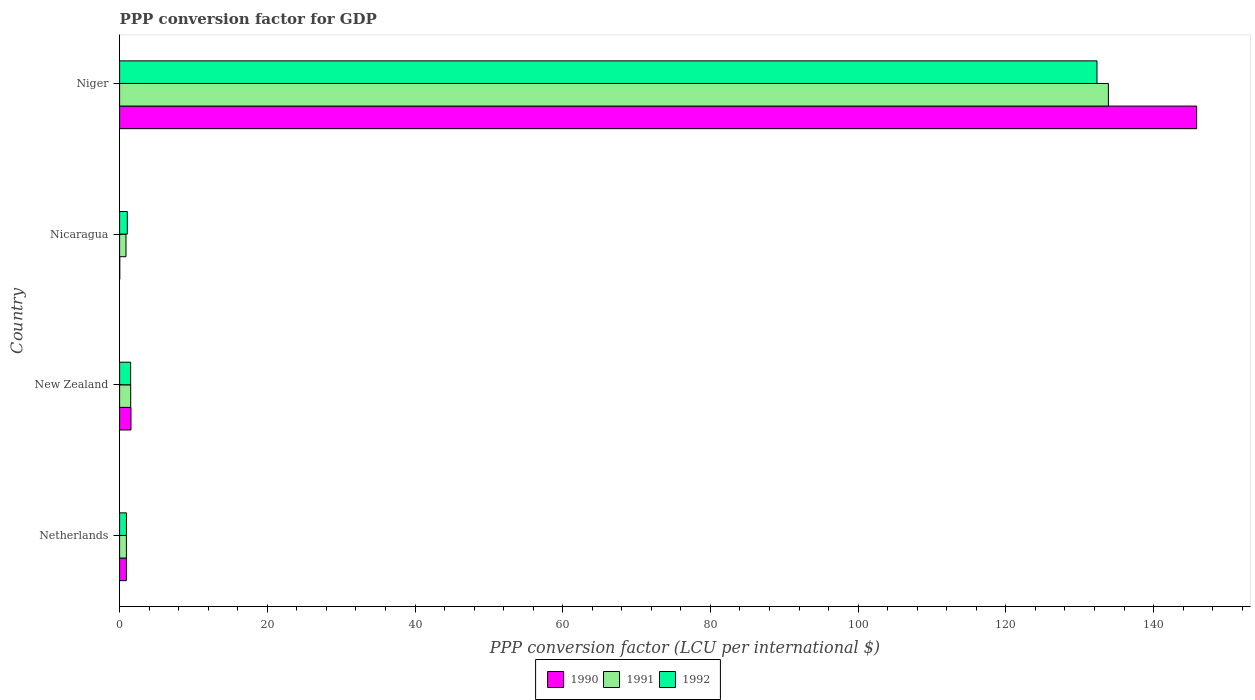How many bars are there on the 3rd tick from the top?
Provide a succinct answer. 3. What is the label of the 2nd group of bars from the top?
Keep it short and to the point. Nicaragua. What is the PPP conversion factor for GDP in 1990 in Nicaragua?
Keep it short and to the point. 0.02. Across all countries, what is the maximum PPP conversion factor for GDP in 1990?
Your answer should be compact. 145.83. Across all countries, what is the minimum PPP conversion factor for GDP in 1991?
Your answer should be very brief. 0.87. In which country was the PPP conversion factor for GDP in 1991 maximum?
Provide a succinct answer. Niger. In which country was the PPP conversion factor for GDP in 1991 minimum?
Give a very brief answer. Nicaragua. What is the total PPP conversion factor for GDP in 1990 in the graph?
Make the answer very short. 148.32. What is the difference between the PPP conversion factor for GDP in 1991 in Netherlands and that in Nicaragua?
Your answer should be very brief. 0.06. What is the difference between the PPP conversion factor for GDP in 1992 in New Zealand and the PPP conversion factor for GDP in 1990 in Nicaragua?
Give a very brief answer. 1.47. What is the average PPP conversion factor for GDP in 1992 per country?
Your answer should be compact. 33.95. What is the difference between the PPP conversion factor for GDP in 1990 and PPP conversion factor for GDP in 1992 in Niger?
Provide a short and direct response. 13.49. What is the ratio of the PPP conversion factor for GDP in 1992 in Netherlands to that in Niger?
Offer a terse response. 0.01. What is the difference between the highest and the second highest PPP conversion factor for GDP in 1991?
Provide a short and direct response. 132.38. What is the difference between the highest and the lowest PPP conversion factor for GDP in 1991?
Provide a short and direct response. 133.02. What does the 1st bar from the bottom in Niger represents?
Provide a short and direct response. 1990. Is it the case that in every country, the sum of the PPP conversion factor for GDP in 1990 and PPP conversion factor for GDP in 1991 is greater than the PPP conversion factor for GDP in 1992?
Provide a succinct answer. No. Are all the bars in the graph horizontal?
Your answer should be very brief. Yes. How many countries are there in the graph?
Ensure brevity in your answer.  4. Are the values on the major ticks of X-axis written in scientific E-notation?
Give a very brief answer. No. How many legend labels are there?
Keep it short and to the point. 3. What is the title of the graph?
Offer a very short reply. PPP conversion factor for GDP. Does "1980" appear as one of the legend labels in the graph?
Your answer should be very brief. No. What is the label or title of the X-axis?
Offer a terse response. PPP conversion factor (LCU per international $). What is the PPP conversion factor (LCU per international $) in 1990 in Netherlands?
Make the answer very short. 0.92. What is the PPP conversion factor (LCU per international $) in 1991 in Netherlands?
Your response must be concise. 0.92. What is the PPP conversion factor (LCU per international $) of 1992 in Netherlands?
Offer a terse response. 0.92. What is the PPP conversion factor (LCU per international $) in 1990 in New Zealand?
Keep it short and to the point. 1.54. What is the PPP conversion factor (LCU per international $) in 1991 in New Zealand?
Ensure brevity in your answer.  1.5. What is the PPP conversion factor (LCU per international $) in 1992 in New Zealand?
Provide a short and direct response. 1.49. What is the PPP conversion factor (LCU per international $) in 1990 in Nicaragua?
Provide a short and direct response. 0.02. What is the PPP conversion factor (LCU per international $) of 1991 in Nicaragua?
Your response must be concise. 0.87. What is the PPP conversion factor (LCU per international $) in 1992 in Nicaragua?
Ensure brevity in your answer.  1.05. What is the PPP conversion factor (LCU per international $) in 1990 in Niger?
Your answer should be compact. 145.83. What is the PPP conversion factor (LCU per international $) of 1991 in Niger?
Make the answer very short. 133.88. What is the PPP conversion factor (LCU per international $) in 1992 in Niger?
Provide a succinct answer. 132.34. Across all countries, what is the maximum PPP conversion factor (LCU per international $) of 1990?
Your response must be concise. 145.83. Across all countries, what is the maximum PPP conversion factor (LCU per international $) of 1991?
Give a very brief answer. 133.88. Across all countries, what is the maximum PPP conversion factor (LCU per international $) in 1992?
Give a very brief answer. 132.34. Across all countries, what is the minimum PPP conversion factor (LCU per international $) of 1990?
Offer a very short reply. 0.02. Across all countries, what is the minimum PPP conversion factor (LCU per international $) in 1991?
Give a very brief answer. 0.87. Across all countries, what is the minimum PPP conversion factor (LCU per international $) of 1992?
Ensure brevity in your answer.  0.92. What is the total PPP conversion factor (LCU per international $) in 1990 in the graph?
Your response must be concise. 148.32. What is the total PPP conversion factor (LCU per international $) in 1991 in the graph?
Provide a succinct answer. 137.17. What is the total PPP conversion factor (LCU per international $) in 1992 in the graph?
Provide a short and direct response. 135.8. What is the difference between the PPP conversion factor (LCU per international $) in 1990 in Netherlands and that in New Zealand?
Offer a terse response. -0.62. What is the difference between the PPP conversion factor (LCU per international $) of 1991 in Netherlands and that in New Zealand?
Your response must be concise. -0.58. What is the difference between the PPP conversion factor (LCU per international $) of 1992 in Netherlands and that in New Zealand?
Offer a terse response. -0.57. What is the difference between the PPP conversion factor (LCU per international $) of 1990 in Netherlands and that in Nicaragua?
Offer a very short reply. 0.9. What is the difference between the PPP conversion factor (LCU per international $) of 1991 in Netherlands and that in Nicaragua?
Offer a very short reply. 0.06. What is the difference between the PPP conversion factor (LCU per international $) of 1992 in Netherlands and that in Nicaragua?
Offer a very short reply. -0.12. What is the difference between the PPP conversion factor (LCU per international $) in 1990 in Netherlands and that in Niger?
Offer a terse response. -144.91. What is the difference between the PPP conversion factor (LCU per international $) of 1991 in Netherlands and that in Niger?
Offer a very short reply. -132.96. What is the difference between the PPP conversion factor (LCU per international $) in 1992 in Netherlands and that in Niger?
Your response must be concise. -131.42. What is the difference between the PPP conversion factor (LCU per international $) in 1990 in New Zealand and that in Nicaragua?
Offer a terse response. 1.52. What is the difference between the PPP conversion factor (LCU per international $) in 1991 in New Zealand and that in Nicaragua?
Ensure brevity in your answer.  0.64. What is the difference between the PPP conversion factor (LCU per international $) in 1992 in New Zealand and that in Nicaragua?
Your answer should be very brief. 0.45. What is the difference between the PPP conversion factor (LCU per international $) in 1990 in New Zealand and that in Niger?
Make the answer very short. -144.29. What is the difference between the PPP conversion factor (LCU per international $) in 1991 in New Zealand and that in Niger?
Provide a short and direct response. -132.38. What is the difference between the PPP conversion factor (LCU per international $) in 1992 in New Zealand and that in Niger?
Make the answer very short. -130.85. What is the difference between the PPP conversion factor (LCU per international $) of 1990 in Nicaragua and that in Niger?
Offer a very short reply. -145.81. What is the difference between the PPP conversion factor (LCU per international $) in 1991 in Nicaragua and that in Niger?
Make the answer very short. -133.02. What is the difference between the PPP conversion factor (LCU per international $) in 1992 in Nicaragua and that in Niger?
Offer a very short reply. -131.29. What is the difference between the PPP conversion factor (LCU per international $) in 1990 in Netherlands and the PPP conversion factor (LCU per international $) in 1991 in New Zealand?
Keep it short and to the point. -0.58. What is the difference between the PPP conversion factor (LCU per international $) in 1990 in Netherlands and the PPP conversion factor (LCU per international $) in 1992 in New Zealand?
Ensure brevity in your answer.  -0.57. What is the difference between the PPP conversion factor (LCU per international $) in 1991 in Netherlands and the PPP conversion factor (LCU per international $) in 1992 in New Zealand?
Provide a succinct answer. -0.57. What is the difference between the PPP conversion factor (LCU per international $) in 1990 in Netherlands and the PPP conversion factor (LCU per international $) in 1991 in Nicaragua?
Ensure brevity in your answer.  0.06. What is the difference between the PPP conversion factor (LCU per international $) of 1990 in Netherlands and the PPP conversion factor (LCU per international $) of 1992 in Nicaragua?
Provide a short and direct response. -0.12. What is the difference between the PPP conversion factor (LCU per international $) in 1991 in Netherlands and the PPP conversion factor (LCU per international $) in 1992 in Nicaragua?
Keep it short and to the point. -0.13. What is the difference between the PPP conversion factor (LCU per international $) in 1990 in Netherlands and the PPP conversion factor (LCU per international $) in 1991 in Niger?
Your answer should be very brief. -132.96. What is the difference between the PPP conversion factor (LCU per international $) in 1990 in Netherlands and the PPP conversion factor (LCU per international $) in 1992 in Niger?
Your response must be concise. -131.42. What is the difference between the PPP conversion factor (LCU per international $) of 1991 in Netherlands and the PPP conversion factor (LCU per international $) of 1992 in Niger?
Make the answer very short. -131.42. What is the difference between the PPP conversion factor (LCU per international $) in 1990 in New Zealand and the PPP conversion factor (LCU per international $) in 1991 in Nicaragua?
Make the answer very short. 0.68. What is the difference between the PPP conversion factor (LCU per international $) in 1990 in New Zealand and the PPP conversion factor (LCU per international $) in 1992 in Nicaragua?
Your response must be concise. 0.5. What is the difference between the PPP conversion factor (LCU per international $) in 1991 in New Zealand and the PPP conversion factor (LCU per international $) in 1992 in Nicaragua?
Provide a succinct answer. 0.46. What is the difference between the PPP conversion factor (LCU per international $) of 1990 in New Zealand and the PPP conversion factor (LCU per international $) of 1991 in Niger?
Your answer should be very brief. -132.34. What is the difference between the PPP conversion factor (LCU per international $) in 1990 in New Zealand and the PPP conversion factor (LCU per international $) in 1992 in Niger?
Your answer should be compact. -130.8. What is the difference between the PPP conversion factor (LCU per international $) of 1991 in New Zealand and the PPP conversion factor (LCU per international $) of 1992 in Niger?
Offer a terse response. -130.84. What is the difference between the PPP conversion factor (LCU per international $) of 1990 in Nicaragua and the PPP conversion factor (LCU per international $) of 1991 in Niger?
Offer a very short reply. -133.86. What is the difference between the PPP conversion factor (LCU per international $) of 1990 in Nicaragua and the PPP conversion factor (LCU per international $) of 1992 in Niger?
Ensure brevity in your answer.  -132.32. What is the difference between the PPP conversion factor (LCU per international $) of 1991 in Nicaragua and the PPP conversion factor (LCU per international $) of 1992 in Niger?
Your answer should be compact. -131.47. What is the average PPP conversion factor (LCU per international $) of 1990 per country?
Offer a terse response. 37.08. What is the average PPP conversion factor (LCU per international $) in 1991 per country?
Offer a very short reply. 34.29. What is the average PPP conversion factor (LCU per international $) in 1992 per country?
Provide a succinct answer. 33.95. What is the difference between the PPP conversion factor (LCU per international $) of 1990 and PPP conversion factor (LCU per international $) of 1991 in Netherlands?
Your answer should be very brief. 0. What is the difference between the PPP conversion factor (LCU per international $) of 1990 and PPP conversion factor (LCU per international $) of 1992 in Netherlands?
Make the answer very short. -0. What is the difference between the PPP conversion factor (LCU per international $) of 1991 and PPP conversion factor (LCU per international $) of 1992 in Netherlands?
Your response must be concise. -0. What is the difference between the PPP conversion factor (LCU per international $) of 1990 and PPP conversion factor (LCU per international $) of 1991 in New Zealand?
Your response must be concise. 0.04. What is the difference between the PPP conversion factor (LCU per international $) in 1990 and PPP conversion factor (LCU per international $) in 1992 in New Zealand?
Give a very brief answer. 0.05. What is the difference between the PPP conversion factor (LCU per international $) in 1991 and PPP conversion factor (LCU per international $) in 1992 in New Zealand?
Provide a succinct answer. 0.01. What is the difference between the PPP conversion factor (LCU per international $) of 1990 and PPP conversion factor (LCU per international $) of 1991 in Nicaragua?
Keep it short and to the point. -0.85. What is the difference between the PPP conversion factor (LCU per international $) of 1990 and PPP conversion factor (LCU per international $) of 1992 in Nicaragua?
Your answer should be compact. -1.03. What is the difference between the PPP conversion factor (LCU per international $) of 1991 and PPP conversion factor (LCU per international $) of 1992 in Nicaragua?
Provide a succinct answer. -0.18. What is the difference between the PPP conversion factor (LCU per international $) of 1990 and PPP conversion factor (LCU per international $) of 1991 in Niger?
Your response must be concise. 11.95. What is the difference between the PPP conversion factor (LCU per international $) of 1990 and PPP conversion factor (LCU per international $) of 1992 in Niger?
Provide a short and direct response. 13.49. What is the difference between the PPP conversion factor (LCU per international $) of 1991 and PPP conversion factor (LCU per international $) of 1992 in Niger?
Provide a short and direct response. 1.54. What is the ratio of the PPP conversion factor (LCU per international $) of 1990 in Netherlands to that in New Zealand?
Your answer should be very brief. 0.6. What is the ratio of the PPP conversion factor (LCU per international $) in 1991 in Netherlands to that in New Zealand?
Give a very brief answer. 0.61. What is the ratio of the PPP conversion factor (LCU per international $) of 1992 in Netherlands to that in New Zealand?
Provide a succinct answer. 0.62. What is the ratio of the PPP conversion factor (LCU per international $) of 1990 in Netherlands to that in Nicaragua?
Keep it short and to the point. 47.73. What is the ratio of the PPP conversion factor (LCU per international $) in 1991 in Netherlands to that in Nicaragua?
Ensure brevity in your answer.  1.06. What is the ratio of the PPP conversion factor (LCU per international $) in 1992 in Netherlands to that in Nicaragua?
Offer a very short reply. 0.88. What is the ratio of the PPP conversion factor (LCU per international $) of 1990 in Netherlands to that in Niger?
Your answer should be compact. 0.01. What is the ratio of the PPP conversion factor (LCU per international $) of 1991 in Netherlands to that in Niger?
Your answer should be compact. 0.01. What is the ratio of the PPP conversion factor (LCU per international $) in 1992 in Netherlands to that in Niger?
Your response must be concise. 0.01. What is the ratio of the PPP conversion factor (LCU per international $) of 1990 in New Zealand to that in Nicaragua?
Provide a short and direct response. 79.72. What is the ratio of the PPP conversion factor (LCU per international $) in 1991 in New Zealand to that in Nicaragua?
Provide a short and direct response. 1.74. What is the ratio of the PPP conversion factor (LCU per international $) in 1992 in New Zealand to that in Nicaragua?
Keep it short and to the point. 1.43. What is the ratio of the PPP conversion factor (LCU per international $) in 1990 in New Zealand to that in Niger?
Ensure brevity in your answer.  0.01. What is the ratio of the PPP conversion factor (LCU per international $) in 1991 in New Zealand to that in Niger?
Your answer should be compact. 0.01. What is the ratio of the PPP conversion factor (LCU per international $) in 1992 in New Zealand to that in Niger?
Keep it short and to the point. 0.01. What is the ratio of the PPP conversion factor (LCU per international $) in 1991 in Nicaragua to that in Niger?
Give a very brief answer. 0.01. What is the ratio of the PPP conversion factor (LCU per international $) of 1992 in Nicaragua to that in Niger?
Your answer should be very brief. 0.01. What is the difference between the highest and the second highest PPP conversion factor (LCU per international $) in 1990?
Offer a terse response. 144.29. What is the difference between the highest and the second highest PPP conversion factor (LCU per international $) of 1991?
Your answer should be very brief. 132.38. What is the difference between the highest and the second highest PPP conversion factor (LCU per international $) of 1992?
Give a very brief answer. 130.85. What is the difference between the highest and the lowest PPP conversion factor (LCU per international $) of 1990?
Your answer should be compact. 145.81. What is the difference between the highest and the lowest PPP conversion factor (LCU per international $) in 1991?
Offer a very short reply. 133.02. What is the difference between the highest and the lowest PPP conversion factor (LCU per international $) of 1992?
Keep it short and to the point. 131.42. 